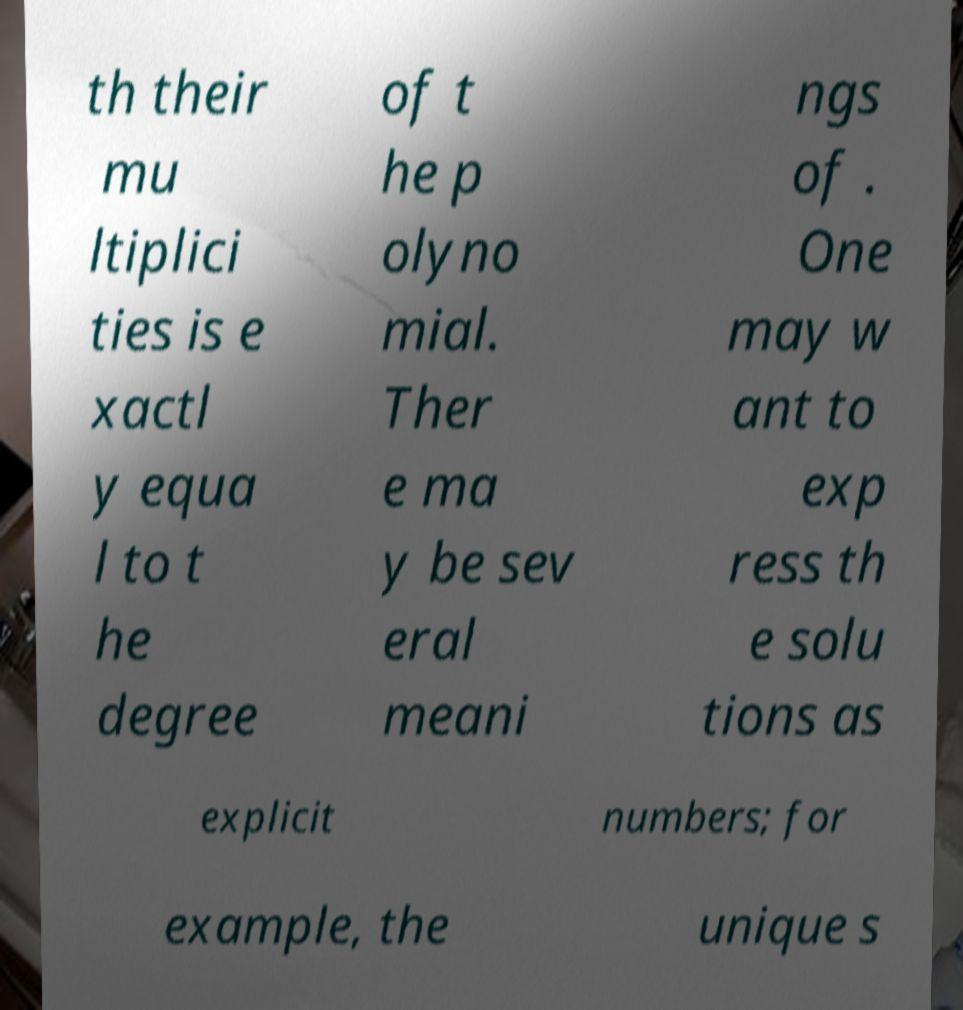Could you extract and type out the text from this image? th their mu ltiplici ties is e xactl y equa l to t he degree of t he p olyno mial. Ther e ma y be sev eral meani ngs of . One may w ant to exp ress th e solu tions as explicit numbers; for example, the unique s 